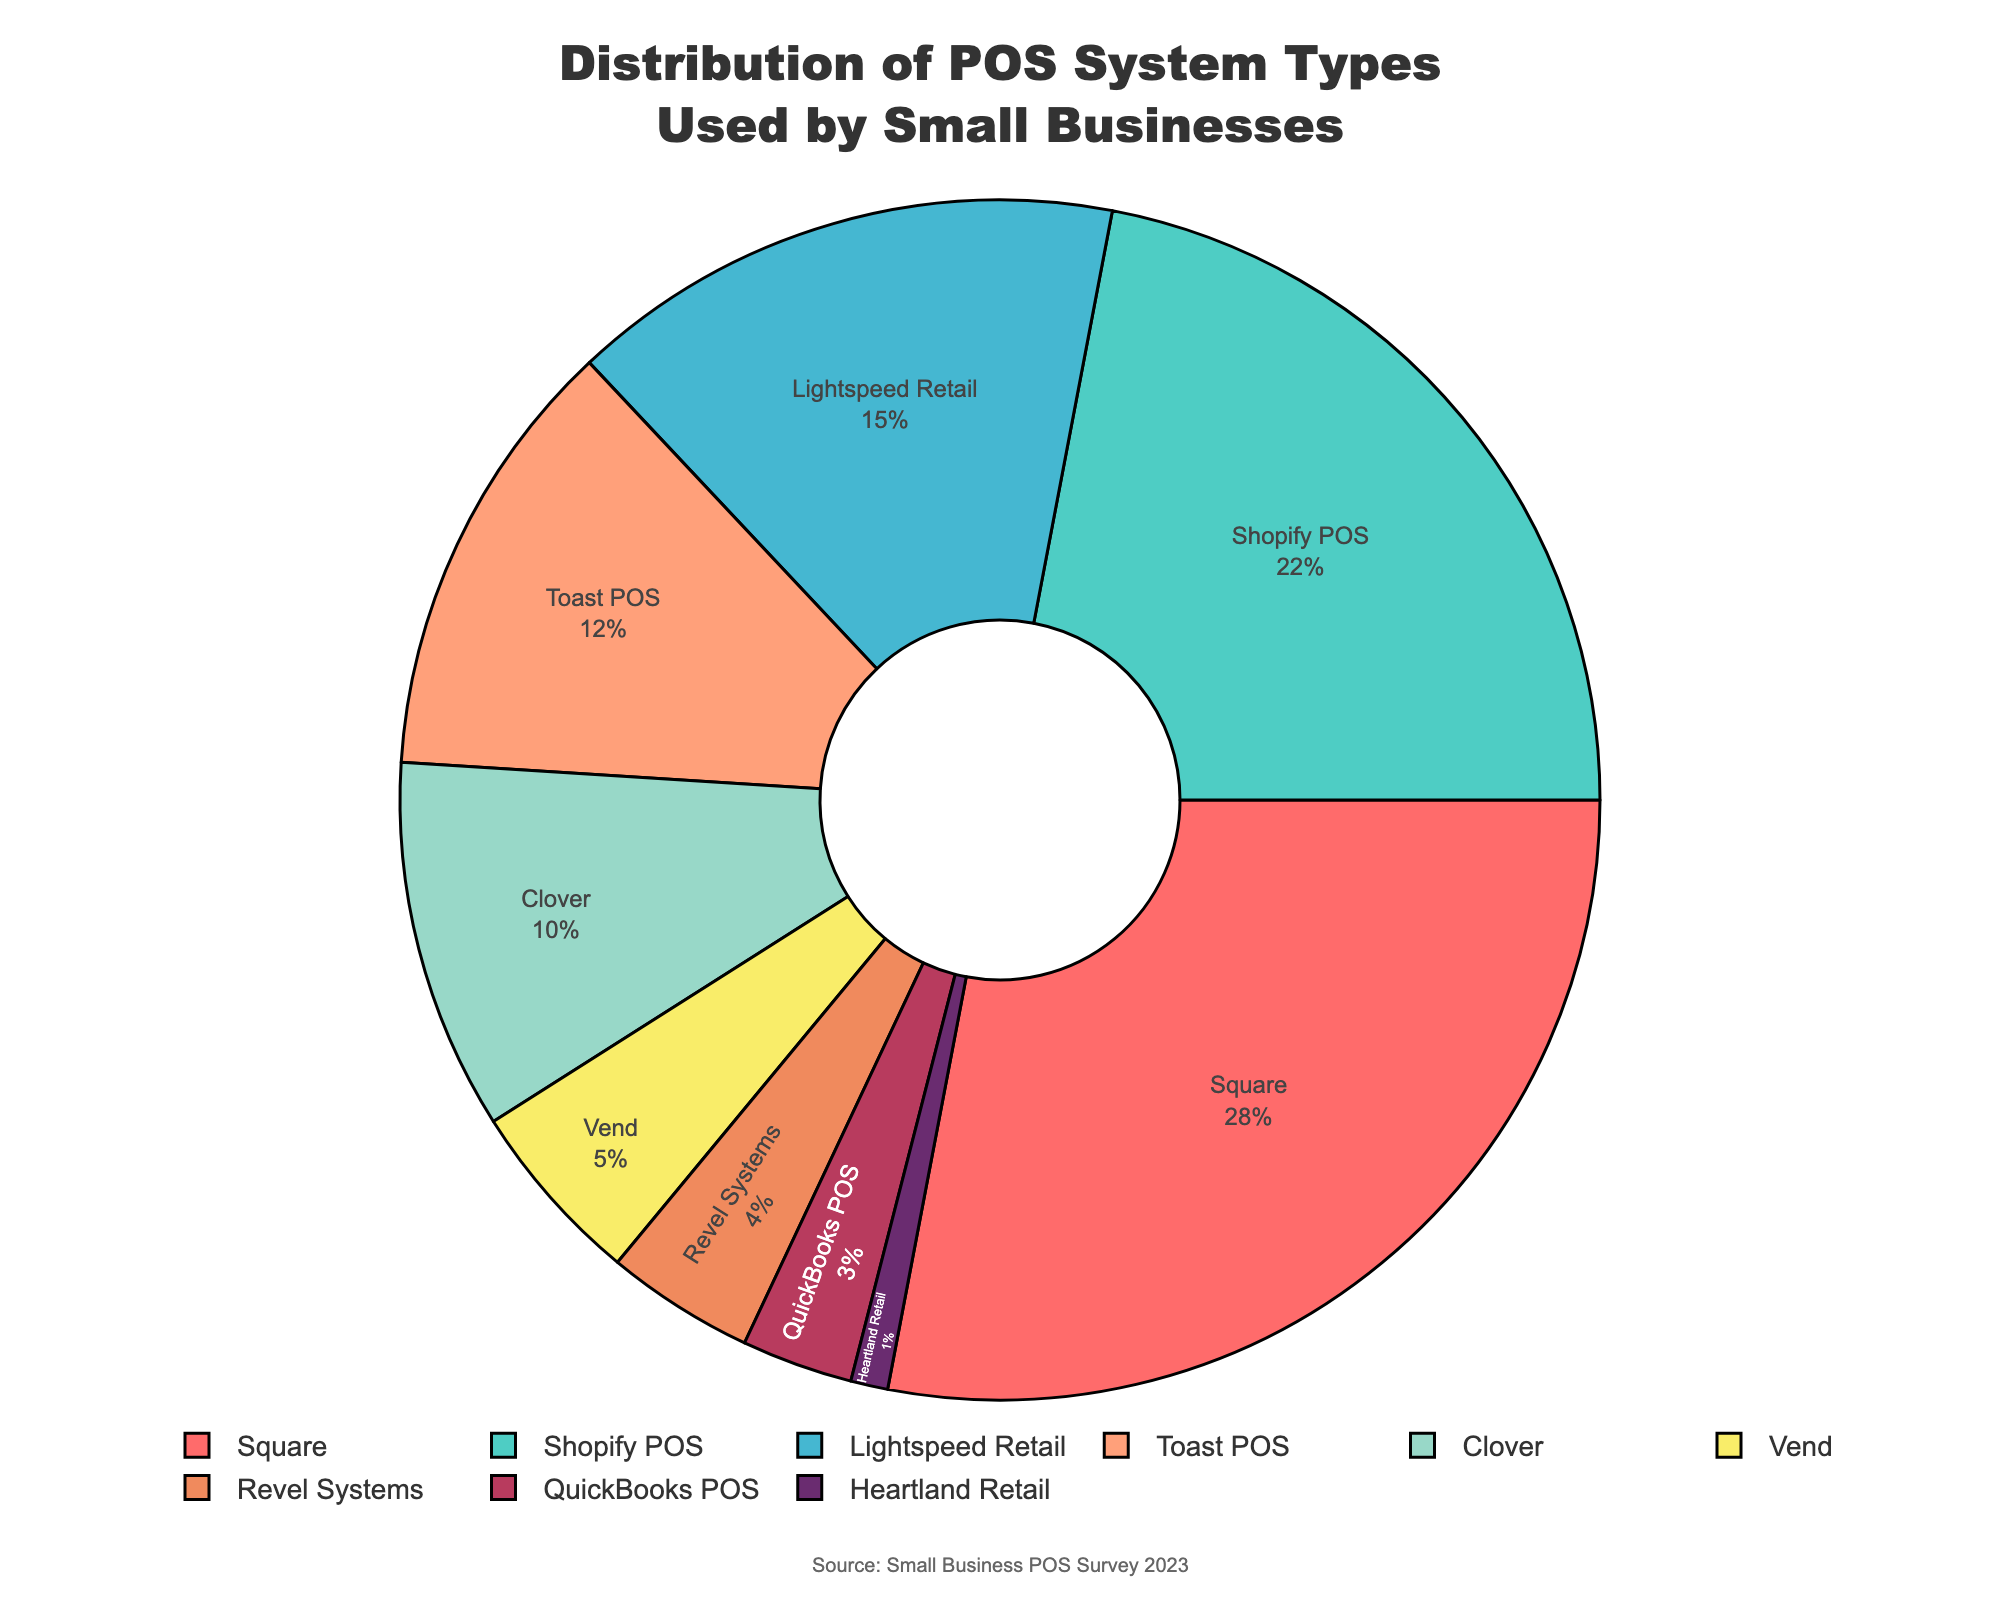What is the most used POS system among small businesses? The figure clearly labels the percentage values for each POS system. The largest slice of the pie chart represents Square with 28%.
Answer: Square Which POS system has the smallest market share? The figure shows the smallest slice in the pie chart to be Heartland Retail with 1%.
Answer: Heartland Retail What percentage of small businesses use either Square or Shopify POS? Sum the percentages for Square (28%) and Shopify POS (22%). So, 28% + 22% = 50%.
Answer: 50% How does Lightspeed Retail compare to Toast POS in terms of usage? Lightspeed Retail has 15% usage, while Toast POS has 12% as shown in the respective slices of the pie chart.
Answer: Lightspeed Retail is used 3% more Rank the POS systems from most used to least used. Based on the percentages: 1) Square (28%), 2) Shopify POS (22%), 3) Lightspeed Retail (15%), 4) Toast POS (12%), 5) Clover (10%), 6) Vend (5%), 7) Revel Systems (4%), 8) QuickBooks POS (3%), 9) Heartland Retail (1%).
Answer: Square, Shopify POS, Lightspeed Retail, Toast POS, Clover, Vend, Revel Systems, QuickBooks POS, Heartland Retail What is the combined percentage of businesses using Clover, Vend, and Revel Systems? Sum the percentages for Clover (10%), Vend (5%), and Revel Systems (4%). So, 10% + 5% + 4% = 19%.
Answer: 19% How much more popular is Square compared to Revel Systems? Subtract the percentage of Revel Systems (4%) from that of Square (28%). So, 28% - 4% = 24%.
Answer: 24% Which POS systems have a combined share of exactly 25%? The systems Vend (5%), Revel Systems (4%), QuickBooks POS (3%), and Heartland Retail (1%) together sum to 5% + 4% + 3% + 1% = 13%. Clover (10%) and Vend (5%) sum to 15%. Based on the pie chart, no combination exactly sums to 25%.
Answer: None Compare the combined usage of Lightspeed Retail and Clover to Toast POS. Sum the percentages of Lightspeed Retail (15%) and Clover (10%). 15% + 10% = 25%, and compare that to Toast POS (12%). 25% is greater than 12%.
Answer: Lightspeed Retail and Clover combined are used 13% more Which color represents the segment for Toast POS? The segment for Toast POS is visually represented in the pie chart in a distinct color (orange).
Answer: Orange 